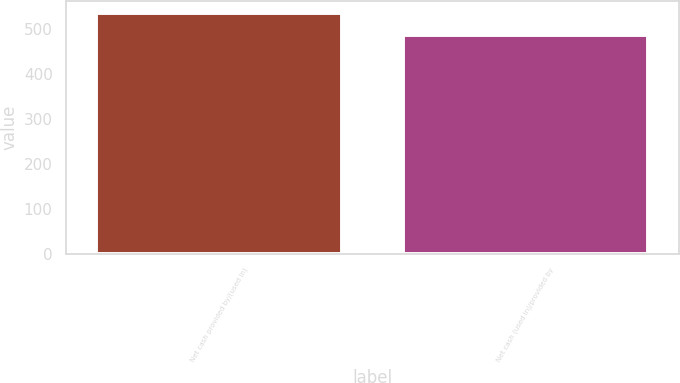Convert chart. <chart><loc_0><loc_0><loc_500><loc_500><bar_chart><fcel>Net cash provided by/(used in)<fcel>Net cash (used in)/provided by<nl><fcel>536.8<fcel>486.9<nl></chart> 